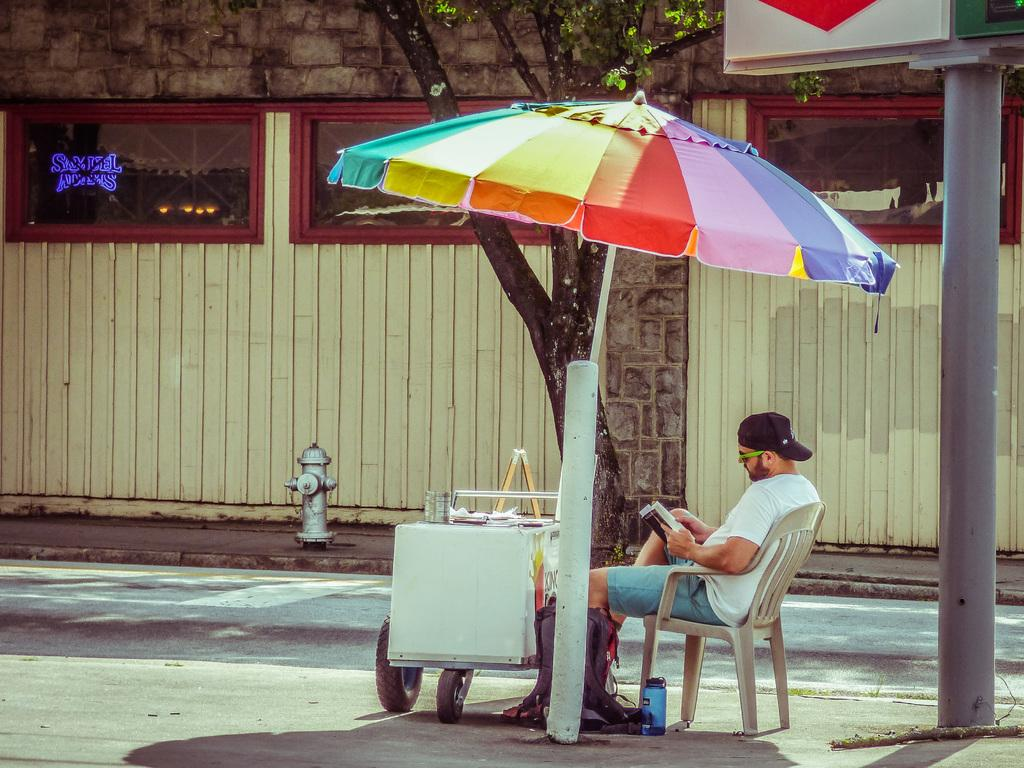What type of structure is visible in the image? There is a brick wall in the image. What natural element is present in the image? There is a tree in the image. What object is used for protection from the elements in the image? There is an umbrella in the image. What is the man in the image doing? The man is sitting on a chair in the image. What type of fork can be seen in the man's hand in the image? There is no fork present in the image; the man is sitting on a chair with no visible objects in his hand. 